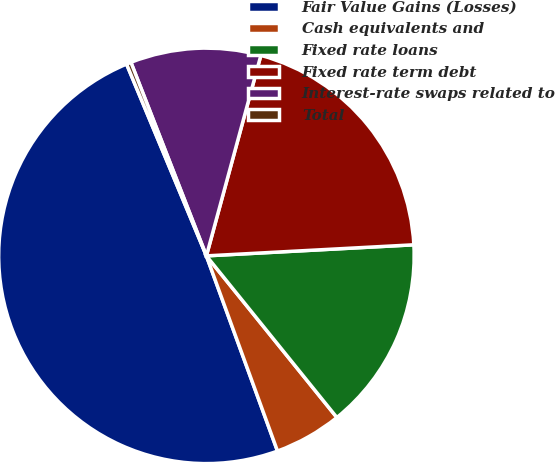<chart> <loc_0><loc_0><loc_500><loc_500><pie_chart><fcel>Fair Value Gains (Losses)<fcel>Cash equivalents and<fcel>Fixed rate loans<fcel>Fixed rate term debt<fcel>Interest-rate swaps related to<fcel>Total<nl><fcel>49.28%<fcel>5.25%<fcel>15.04%<fcel>19.93%<fcel>10.14%<fcel>0.36%<nl></chart> 